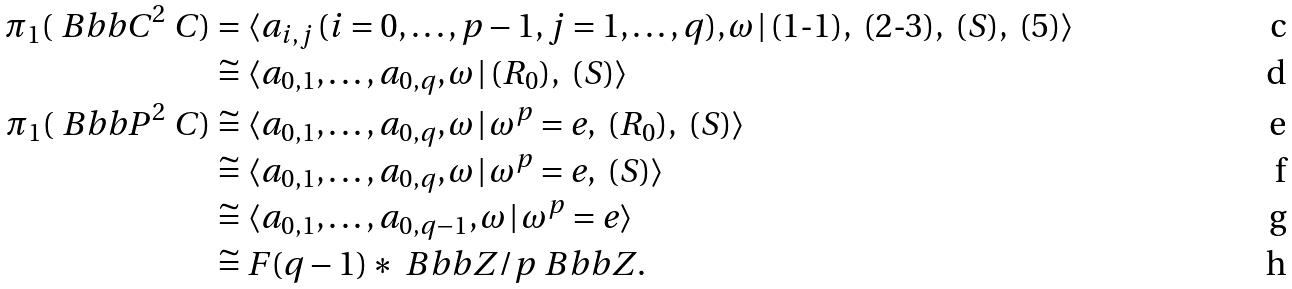Convert formula to latex. <formula><loc_0><loc_0><loc_500><loc_500>\pi _ { 1 } ( \ B b b { C } ^ { 2 } \ C ) & = \langle a _ { i , j } \, ( i = 0 , \dots , p - 1 , j = 1 , \dots , q ) , \omega \, | \, ( 1 { \text {-} 1 } ) , \ ( 2 { \text {-} } 3 ) , \ ( S ) , \ ( 5 ) \rangle \\ & \cong \langle a _ { 0 , 1 } , \dots , a _ { 0 , q } , \omega \, | \, ( R _ { 0 } ) , \ ( S ) \rangle \\ \pi _ { 1 } ( \ B b b { P } ^ { 2 } \ C ) & \cong \langle a _ { 0 , 1 } , \dots , a _ { 0 , q } , \omega \, | \, \omega ^ { p } = e , \ ( R _ { 0 } ) , \ ( S ) \rangle \\ & \cong \langle a _ { 0 , 1 } , \dots , a _ { 0 , q } , \omega \, | \, \omega ^ { p } = e , \ ( S ) \rangle \\ & \cong \langle a _ { 0 , 1 } , \dots , a _ { 0 , q - 1 } , \omega \, | \, \omega ^ { p } = e \rangle \\ & \cong F ( q - 1 ) * \ B b b { Z } / p \ B b b { Z } .</formula> 